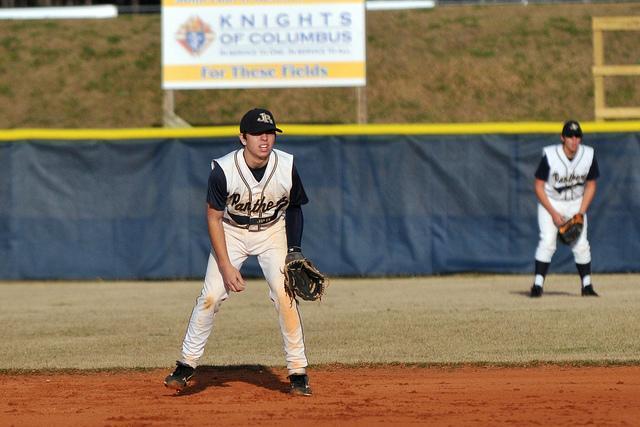How many people are there?
Give a very brief answer. 2. 